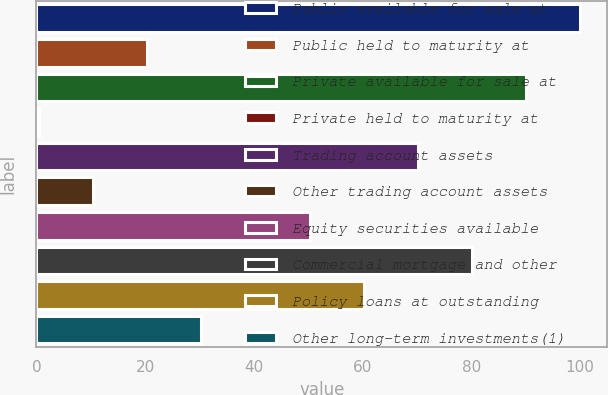<chart> <loc_0><loc_0><loc_500><loc_500><bar_chart><fcel>Public available for sale at<fcel>Public held to maturity at<fcel>Private available for sale at<fcel>Private held to maturity at<fcel>Trading account assets<fcel>Other trading account assets<fcel>Equity securities available<fcel>Commercial mortgage and other<fcel>Policy loans at outstanding<fcel>Other long-term investments(1)<nl><fcel>100<fcel>20.4<fcel>90.05<fcel>0.5<fcel>70.15<fcel>10.45<fcel>50.25<fcel>80.1<fcel>60.2<fcel>30.35<nl></chart> 